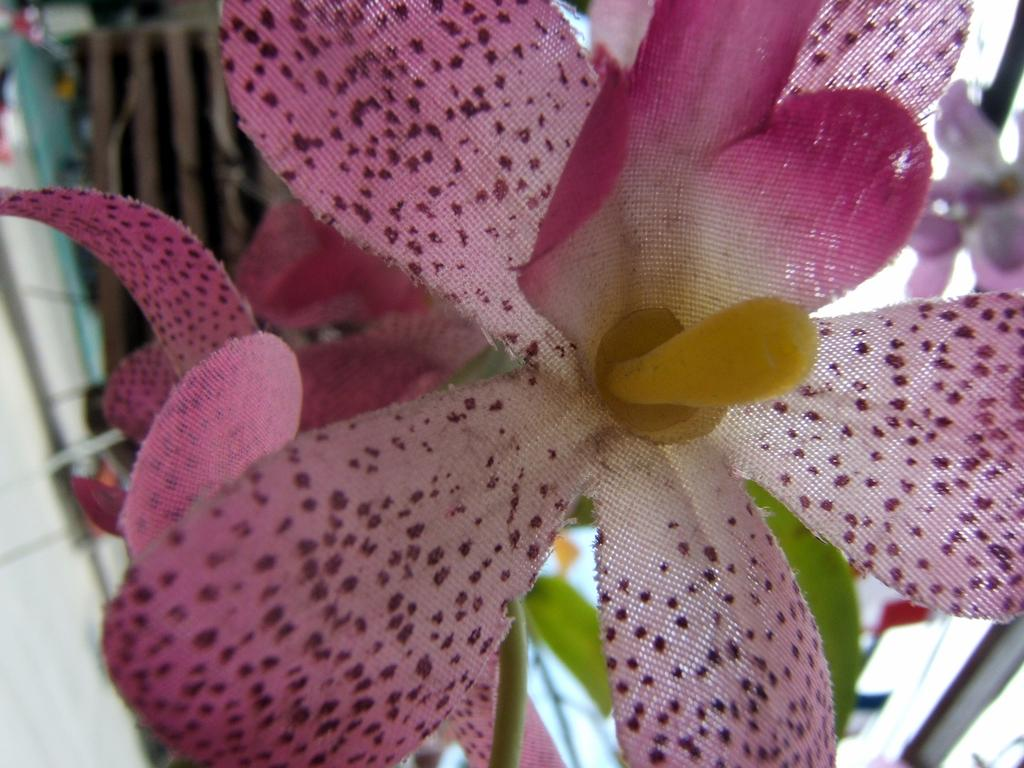What type of decorative elements can be seen in the image? There are decorative flowers in the image. Can you describe the background of the image? The background of the image is blurred. What hobbies are the members of the group engaged in while standing near the tree in the image? There is no group or tree present in the image; it only features decorative flowers and a blurred background. 